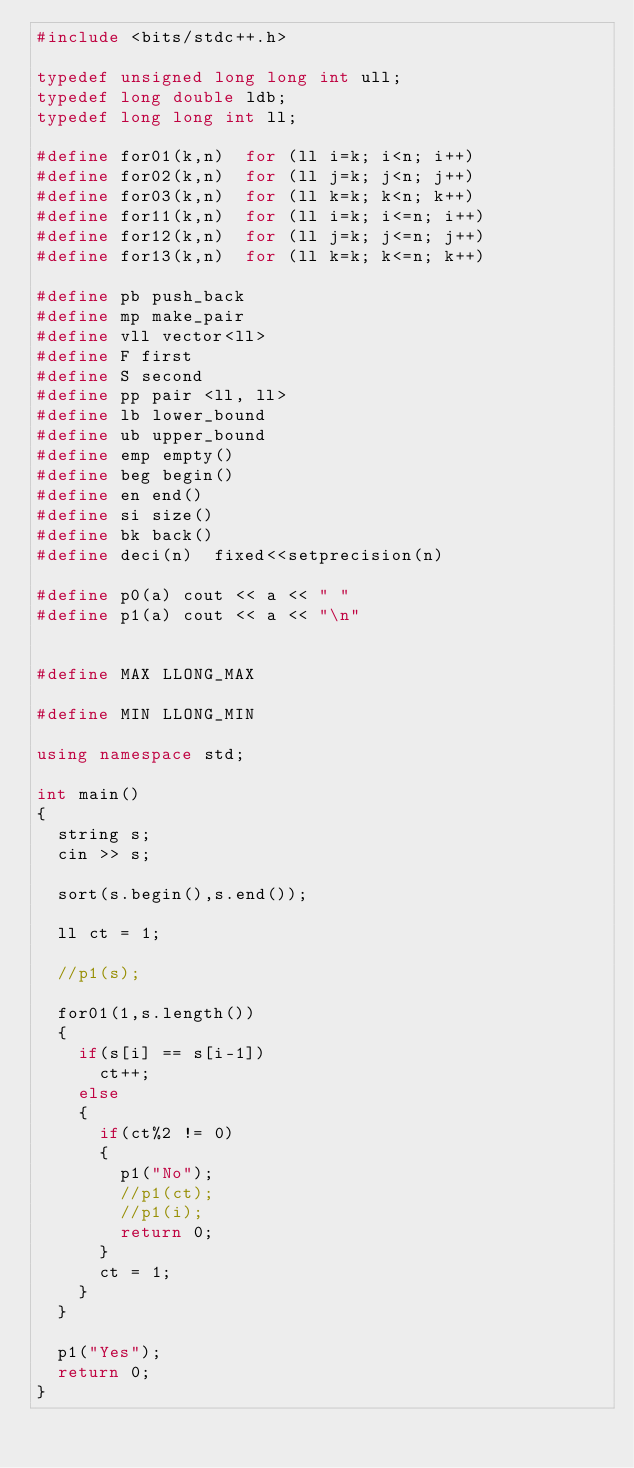<code> <loc_0><loc_0><loc_500><loc_500><_C++_>#include <bits/stdc++.h>
 
typedef unsigned long long int ull;
typedef long double ldb;
typedef long long int ll;
 
#define for01(k,n)  for (ll i=k; i<n; i++)
#define for02(k,n)  for (ll j=k; j<n; j++)
#define for03(k,n)  for (ll k=k; k<n; k++)
#define for11(k,n)  for (ll i=k; i<=n; i++)
#define for12(k,n)  for (ll j=k; j<=n; j++)
#define for13(k,n)  for (ll k=k; k<=n; k++)

#define pb push_back
#define mp make_pair
#define vll vector<ll>
#define F first
#define S second
#define pp pair <ll, ll>
#define lb lower_bound
#define ub upper_bound
#define emp empty()
#define beg begin()
#define en end()
#define si size()
#define bk back()
#define deci(n)  fixed<<setprecision(n)

#define p0(a) cout << a << " "
#define p1(a) cout << a << "\n"


#define MAX LLONG_MAX

#define MIN LLONG_MIN

using namespace std;

int main()
{
  string s;
  cin >> s;
  
  sort(s.begin(),s.end());
  
  ll ct = 1;
  
  //p1(s);
  
  for01(1,s.length())
  {
    if(s[i] == s[i-1])
      ct++;
    else
    {
      if(ct%2 != 0)
      {
        p1("No");
        //p1(ct);
        //p1(i);
        return 0;
      }
      ct = 1;
    }
  }
  
  p1("Yes");
  return 0;
}</code> 